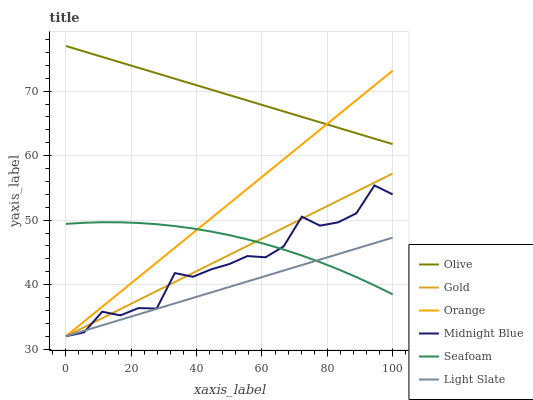Does Light Slate have the minimum area under the curve?
Answer yes or no. Yes. Does Olive have the maximum area under the curve?
Answer yes or no. Yes. Does Gold have the minimum area under the curve?
Answer yes or no. No. Does Gold have the maximum area under the curve?
Answer yes or no. No. Is Light Slate the smoothest?
Answer yes or no. Yes. Is Midnight Blue the roughest?
Answer yes or no. Yes. Is Gold the smoothest?
Answer yes or no. No. Is Gold the roughest?
Answer yes or no. No. Does Midnight Blue have the lowest value?
Answer yes or no. Yes. Does Seafoam have the lowest value?
Answer yes or no. No. Does Olive have the highest value?
Answer yes or no. Yes. Does Gold have the highest value?
Answer yes or no. No. Is Seafoam less than Olive?
Answer yes or no. Yes. Is Olive greater than Seafoam?
Answer yes or no. Yes. Does Olive intersect Orange?
Answer yes or no. Yes. Is Olive less than Orange?
Answer yes or no. No. Is Olive greater than Orange?
Answer yes or no. No. Does Seafoam intersect Olive?
Answer yes or no. No. 